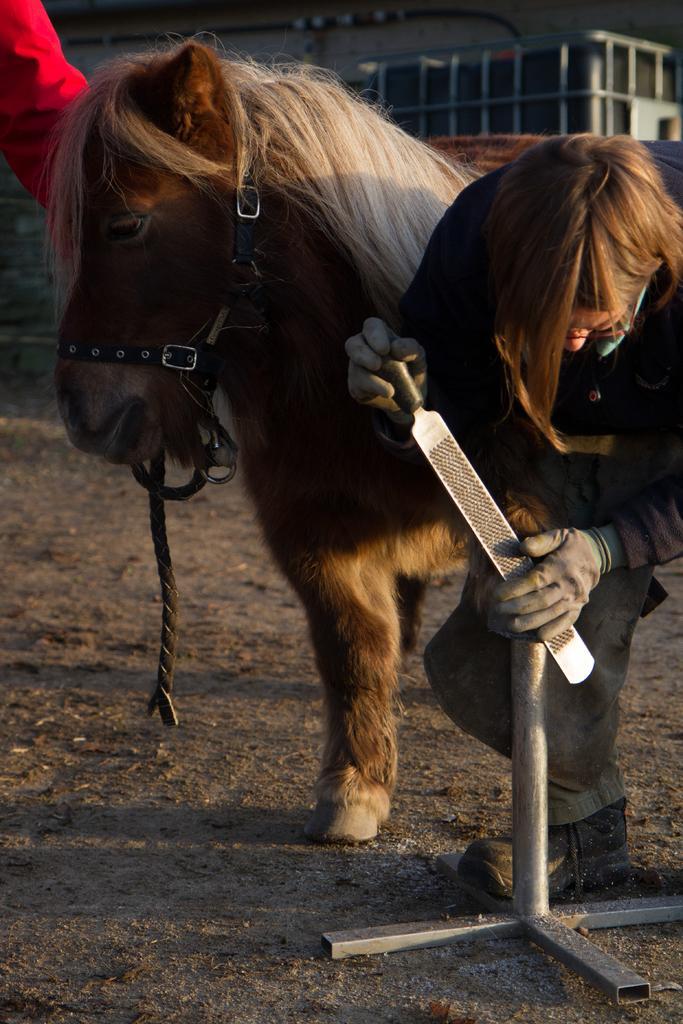Could you give a brief overview of what you see in this image? In front of the image there is a person holding some object. Behind her there is a horse and we can see the hand of a person. In the background of the image there is a building. 